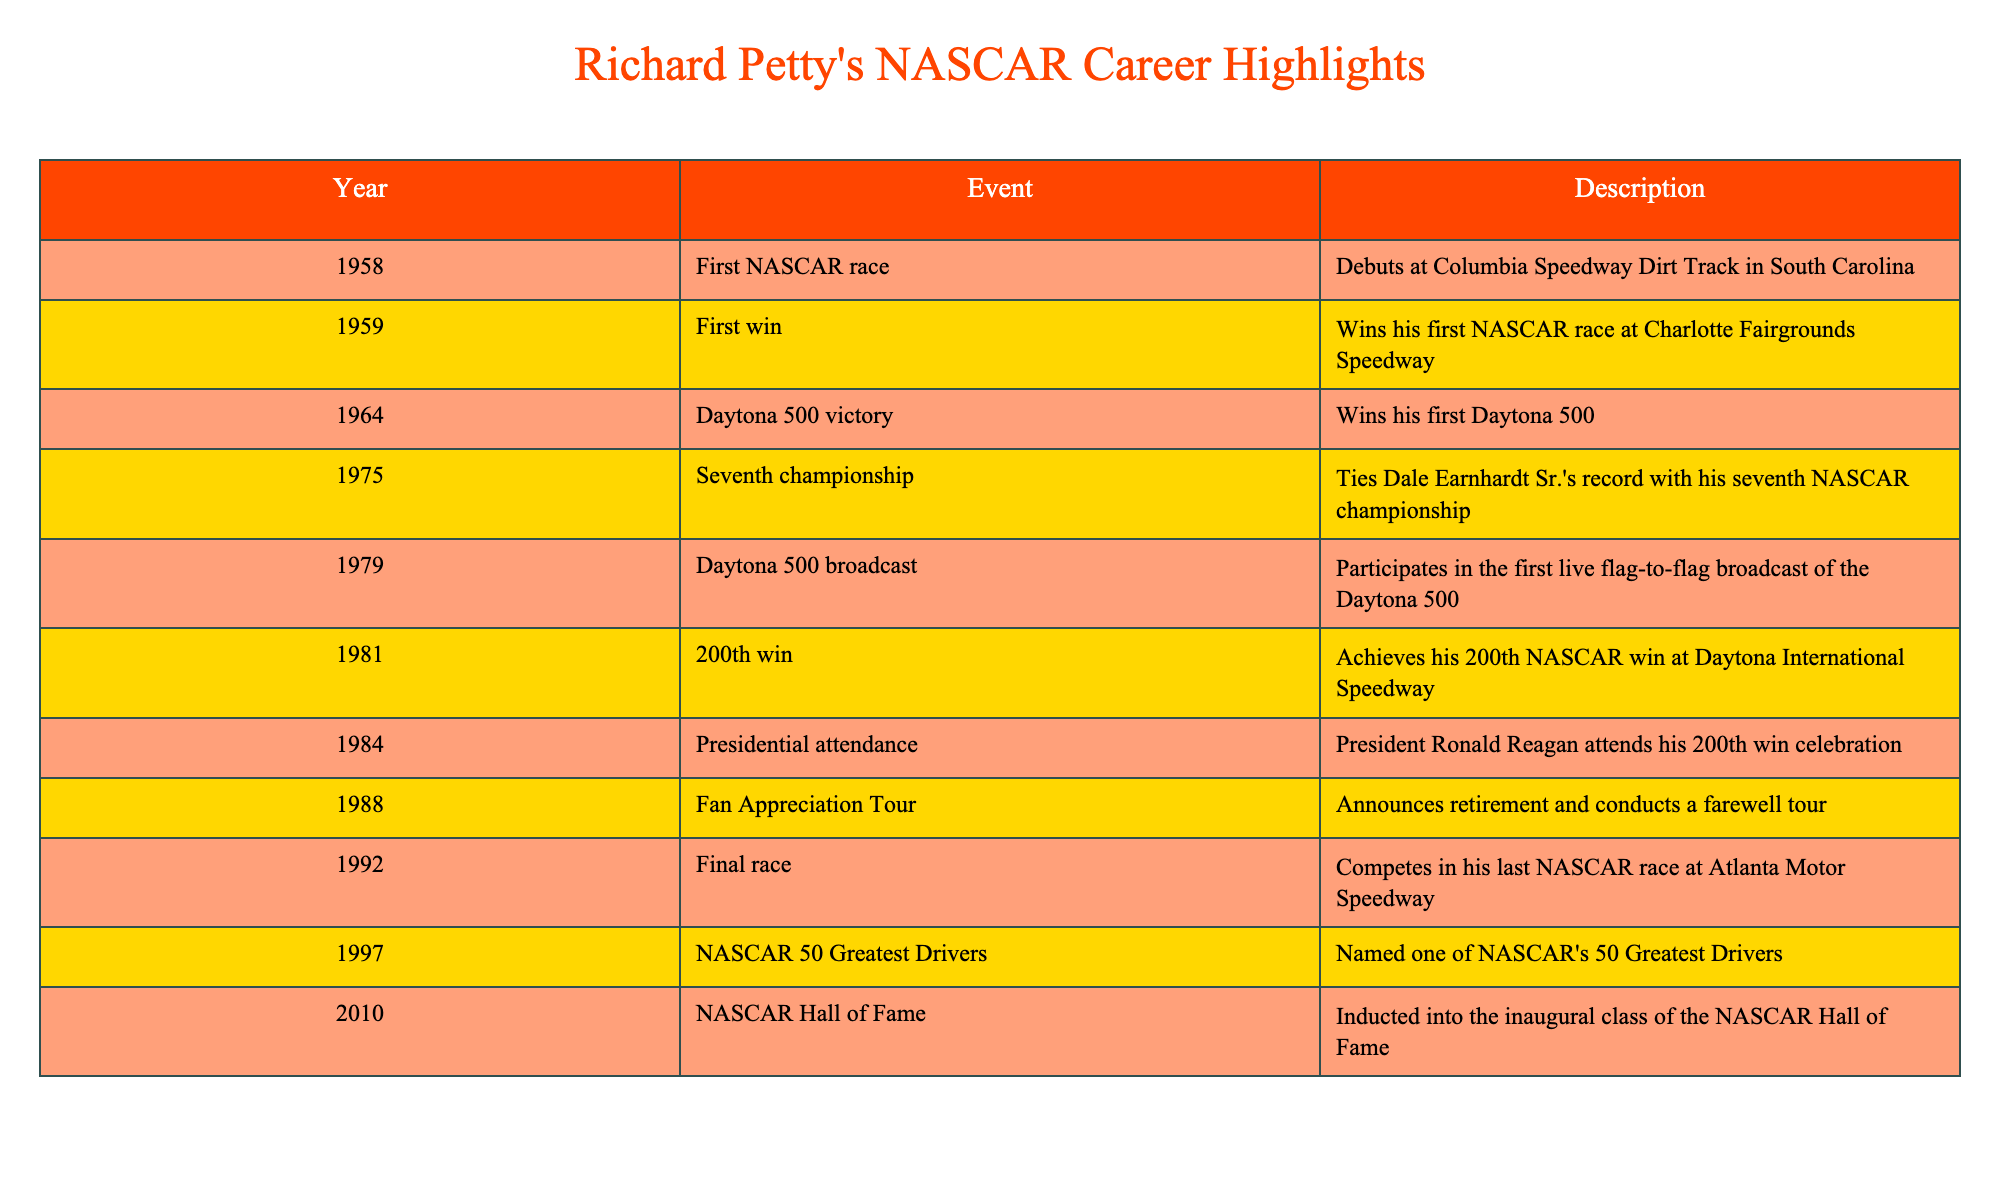What year did Richard Petty win his first NASCAR race? According to the table, Richard Petty won his first NASCAR race in 1959. This information is found in the row detailing his first win.
Answer: 1959 How many NASCAR championships did Richard Petty win? The table indicates that Richard Petty won a total of seven NASCAR championships, as stated in the 1975 entry where he tied Dale Earnhardt Sr.'s record.
Answer: Seven What event marked Richard Petty's 200th win? The table shows that Richard Petty achieved his 200th win in 1981 at Daytona International Speedway. This entry specifically details the milestone event of his career.
Answer: 200th win at Daytona International Speedway Did Richard Petty retire before or after being inducted into the NASCAR Hall of Fame? The table data indicates that Petty announced his retirement in 1988 and was inducted into the NASCAR Hall of Fame in 2010. Therefore, he retired before this induction.
Answer: Before What is the difference in years between Petty's first NASCAR race and his last race? Richard Petty's first NASCAR race was in 1958 and his last race was in 1992. The difference is calculated as 1992 - 1958 = 34 years.
Answer: 34 years Which event was the first live flag-to-flag broadcast of the Daytona 500? The table states that in 1979, Richard Petty participated in the first live flag-to-flag broadcast of the Daytona 500, making this the specific event referred to in the question.
Answer: 1979 In which year did President Ronald Reagan attend a Richard Petty celebration? According to the table, President Ronald Reagan attended Richard Petty's 200th win celebration in 1984, as noted in the corresponding entry for that year.
Answer: 1984 How many years passed between Richard Petty's announcement of retirement and his final race? Richard Petty announced his retirement in 1988 and his final race was in 1992. The time passed is calculated as 1992 - 1988 = 4 years.
Answer: 4 years Was Richard Petty recognized as one of NASCAR's 50 Greatest Drivers? The table highlights that in 1997, Richard Petty was named as one of NASCAR's 50 Greatest Drivers, confirming he received this recognition.
Answer: Yes 